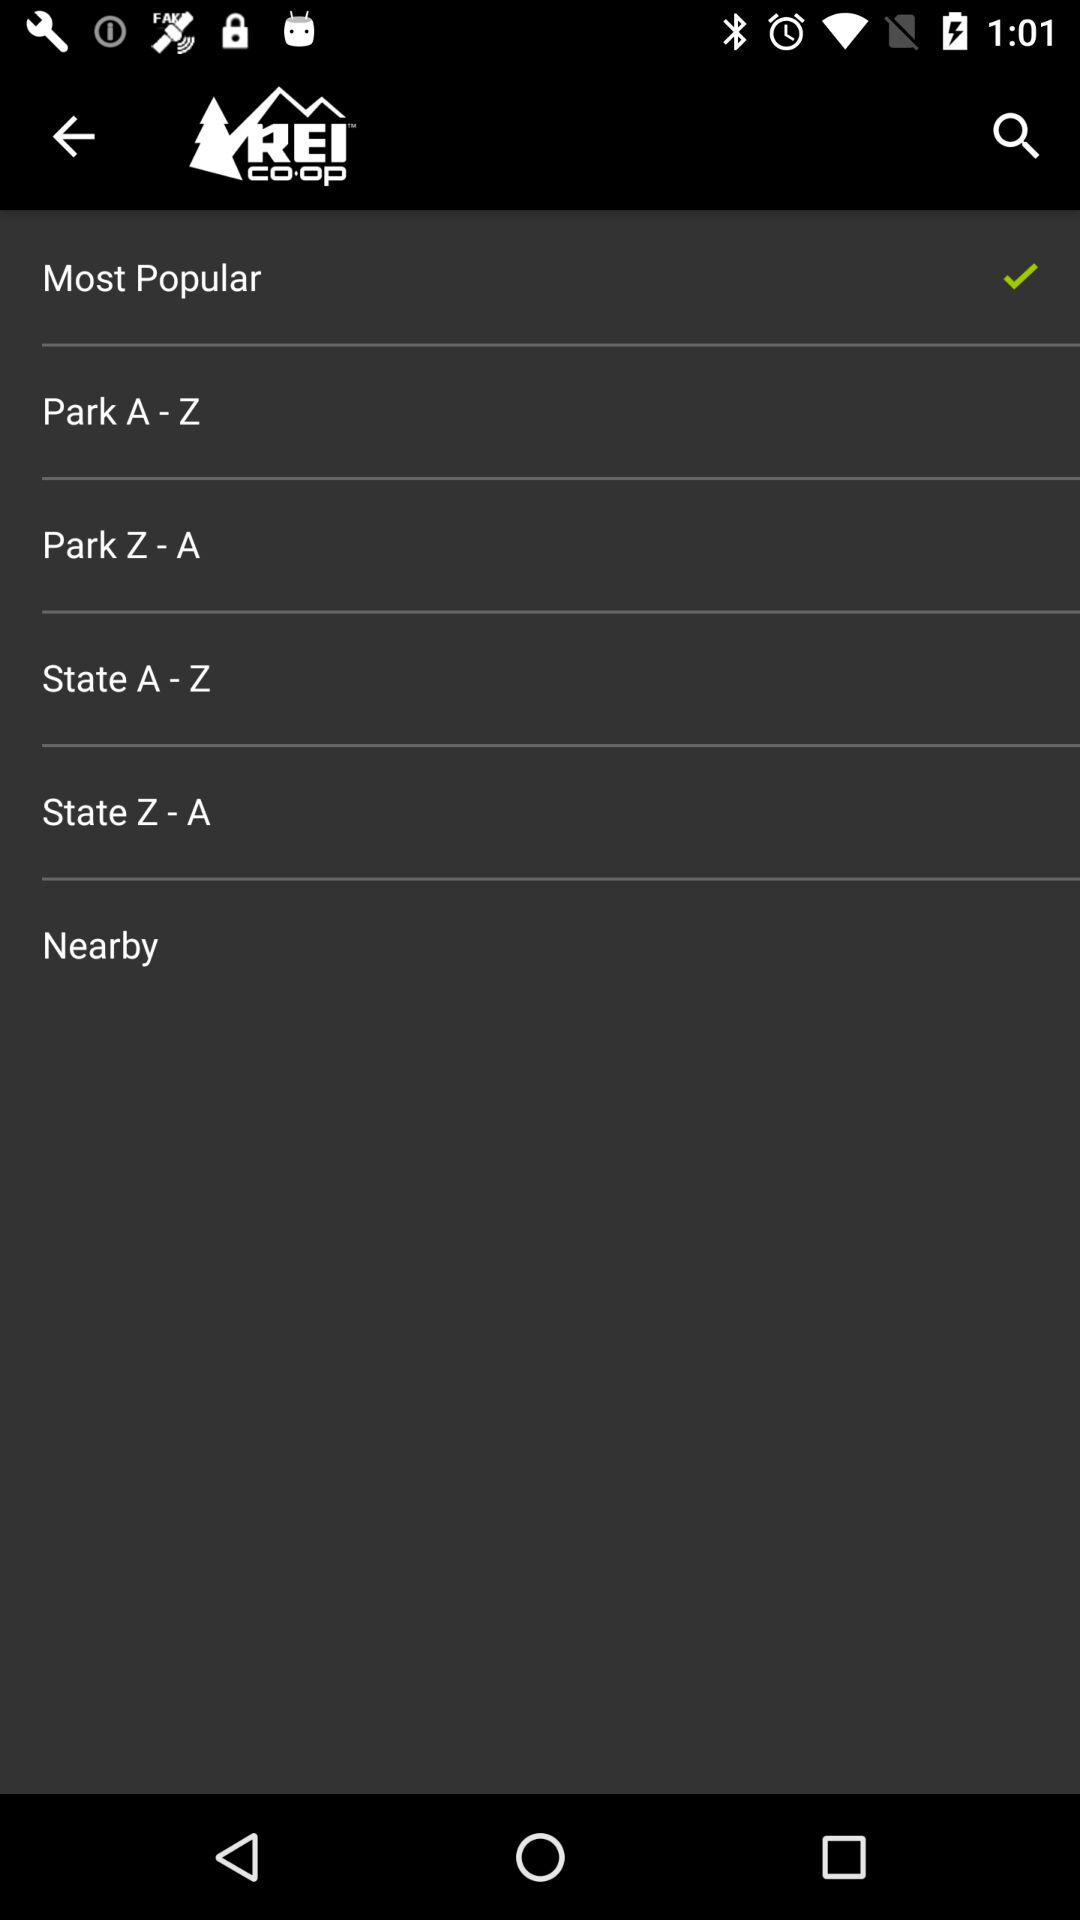Which option is selected? The selected option is "Most Popular". 